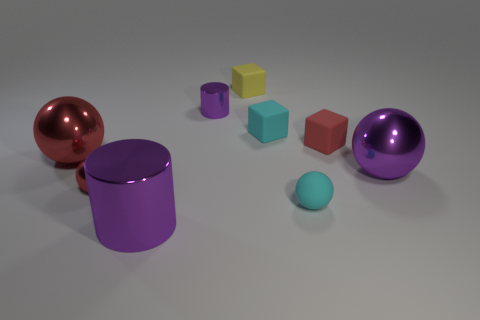Subtract all purple blocks. Subtract all purple spheres. How many blocks are left? 3 Add 1 large brown shiny balls. How many objects exist? 10 Subtract all balls. How many objects are left? 5 Subtract 0 gray spheres. How many objects are left? 9 Subtract all gray cubes. Subtract all cyan things. How many objects are left? 7 Add 4 big things. How many big things are left? 7 Add 5 matte spheres. How many matte spheres exist? 6 